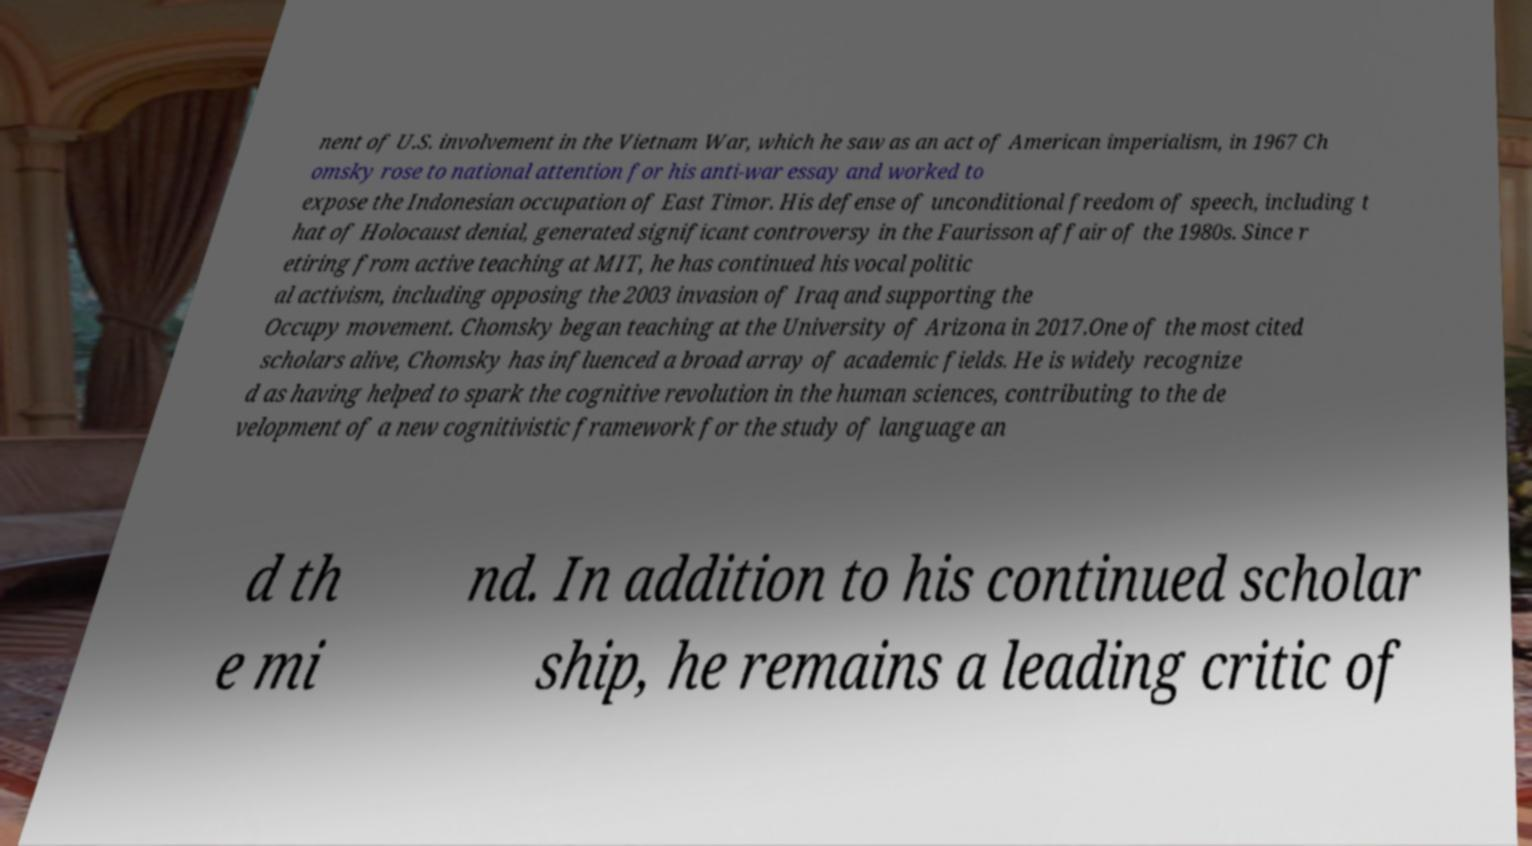There's text embedded in this image that I need extracted. Can you transcribe it verbatim? nent of U.S. involvement in the Vietnam War, which he saw as an act of American imperialism, in 1967 Ch omsky rose to national attention for his anti-war essay and worked to expose the Indonesian occupation of East Timor. His defense of unconditional freedom of speech, including t hat of Holocaust denial, generated significant controversy in the Faurisson affair of the 1980s. Since r etiring from active teaching at MIT, he has continued his vocal politic al activism, including opposing the 2003 invasion of Iraq and supporting the Occupy movement. Chomsky began teaching at the University of Arizona in 2017.One of the most cited scholars alive, Chomsky has influenced a broad array of academic fields. He is widely recognize d as having helped to spark the cognitive revolution in the human sciences, contributing to the de velopment of a new cognitivistic framework for the study of language an d th e mi nd. In addition to his continued scholar ship, he remains a leading critic of 